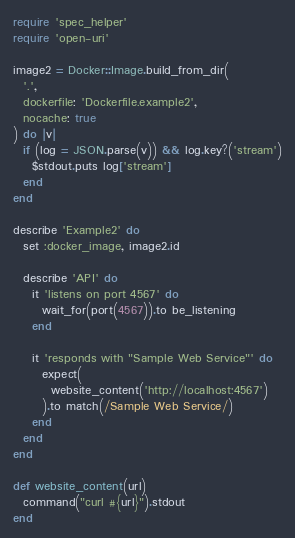Convert code to text. <code><loc_0><loc_0><loc_500><loc_500><_Ruby_>require 'spec_helper'
require 'open-uri'

image2 = Docker::Image.build_from_dir(
  '.',
  dockerfile: 'Dockerfile.example2',
  nocache: true
) do |v|
  if (log = JSON.parse(v)) && log.key?('stream')
    $stdout.puts log['stream']
  end
end

describe 'Example2' do
  set :docker_image, image2.id

  describe 'API' do
    it 'listens on port 4567' do
      wait_for(port(4567)).to be_listening
    end

    it 'responds with "Sample Web Service"' do
      expect(
        website_content('http://localhost:4567')
      ).to match(/Sample Web Service/)
    end
  end
end

def website_content(url)
  command("curl #{url}").stdout
end
</code> 